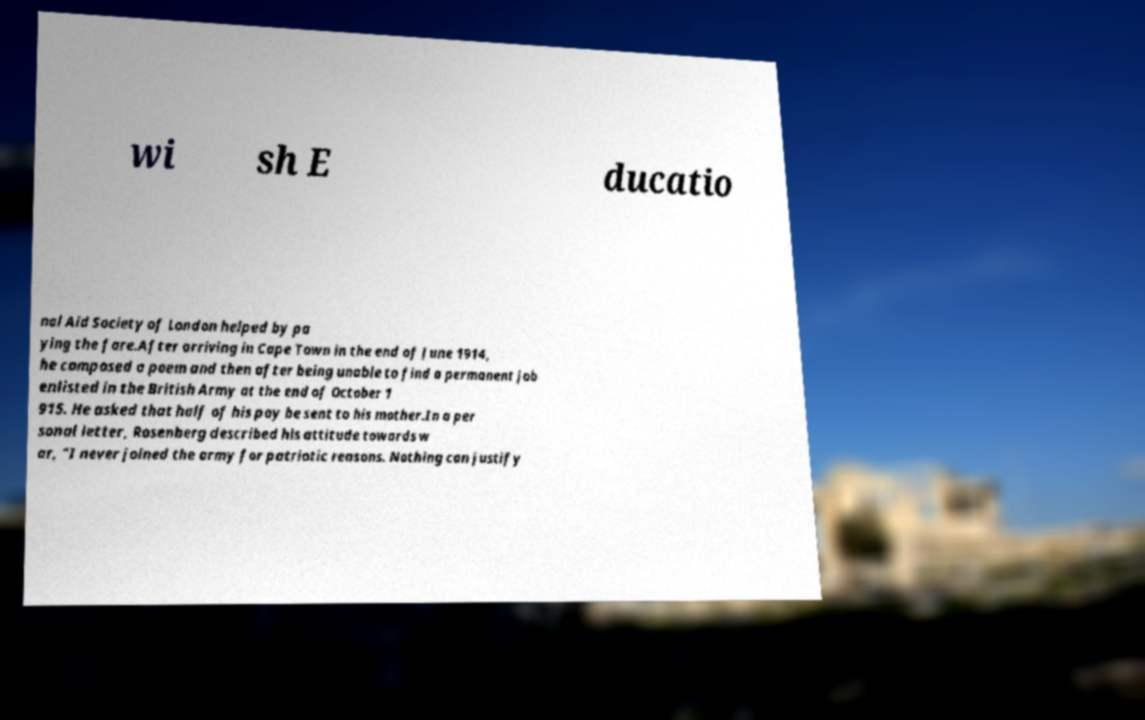Please identify and transcribe the text found in this image. wi sh E ducatio nal Aid Society of London helped by pa ying the fare.After arriving in Cape Town in the end of June 1914, he composed a poem and then after being unable to find a permanent job enlisted in the British Army at the end of October 1 915. He asked that half of his pay be sent to his mother.In a per sonal letter, Rosenberg described his attitude towards w ar, "I never joined the army for patriotic reasons. Nothing can justify 